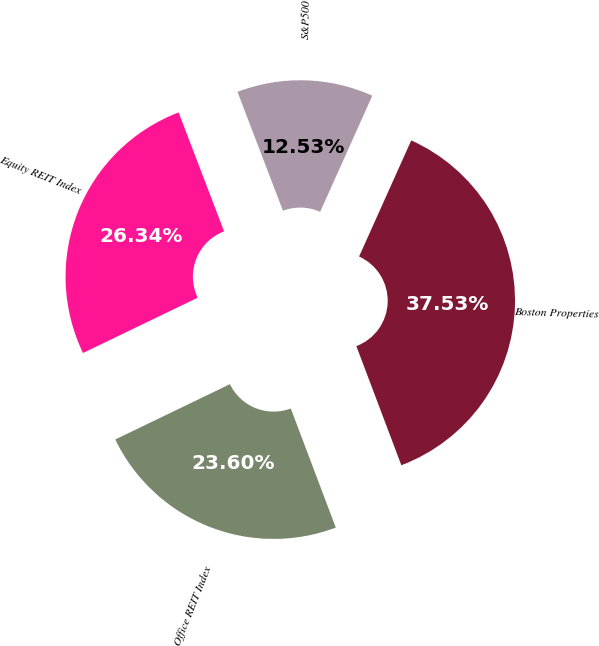Convert chart to OTSL. <chart><loc_0><loc_0><loc_500><loc_500><pie_chart><fcel>Boston Properties<fcel>S&P500<fcel>Equity REIT Index<fcel>Office REIT Index<nl><fcel>37.53%<fcel>12.53%<fcel>26.34%<fcel>23.6%<nl></chart> 